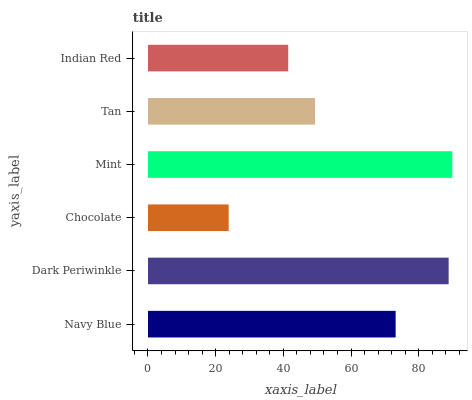Is Chocolate the minimum?
Answer yes or no. Yes. Is Mint the maximum?
Answer yes or no. Yes. Is Dark Periwinkle the minimum?
Answer yes or no. No. Is Dark Periwinkle the maximum?
Answer yes or no. No. Is Dark Periwinkle greater than Navy Blue?
Answer yes or no. Yes. Is Navy Blue less than Dark Periwinkle?
Answer yes or no. Yes. Is Navy Blue greater than Dark Periwinkle?
Answer yes or no. No. Is Dark Periwinkle less than Navy Blue?
Answer yes or no. No. Is Navy Blue the high median?
Answer yes or no. Yes. Is Tan the low median?
Answer yes or no. Yes. Is Chocolate the high median?
Answer yes or no. No. Is Chocolate the low median?
Answer yes or no. No. 